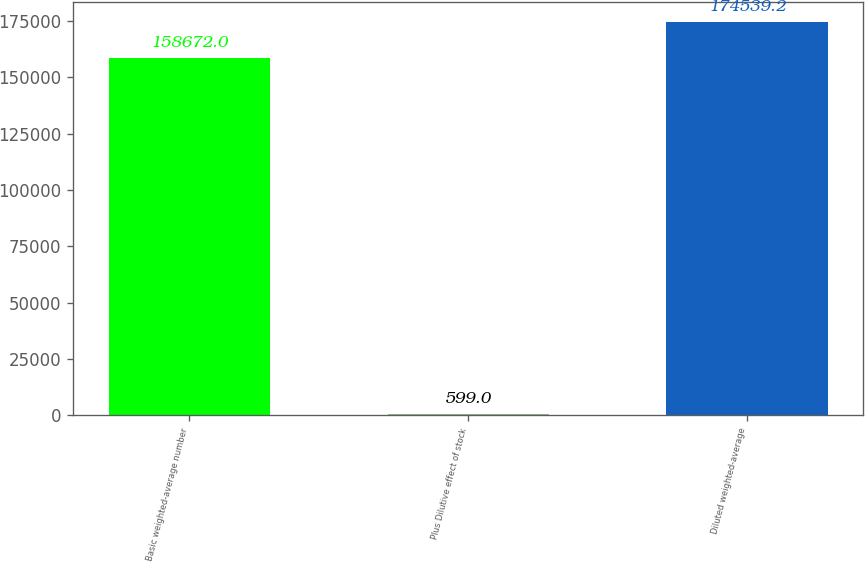<chart> <loc_0><loc_0><loc_500><loc_500><bar_chart><fcel>Basic weighted-average number<fcel>Plus Dilutive effect of stock<fcel>Diluted weighted-average<nl><fcel>158672<fcel>599<fcel>174539<nl></chart> 